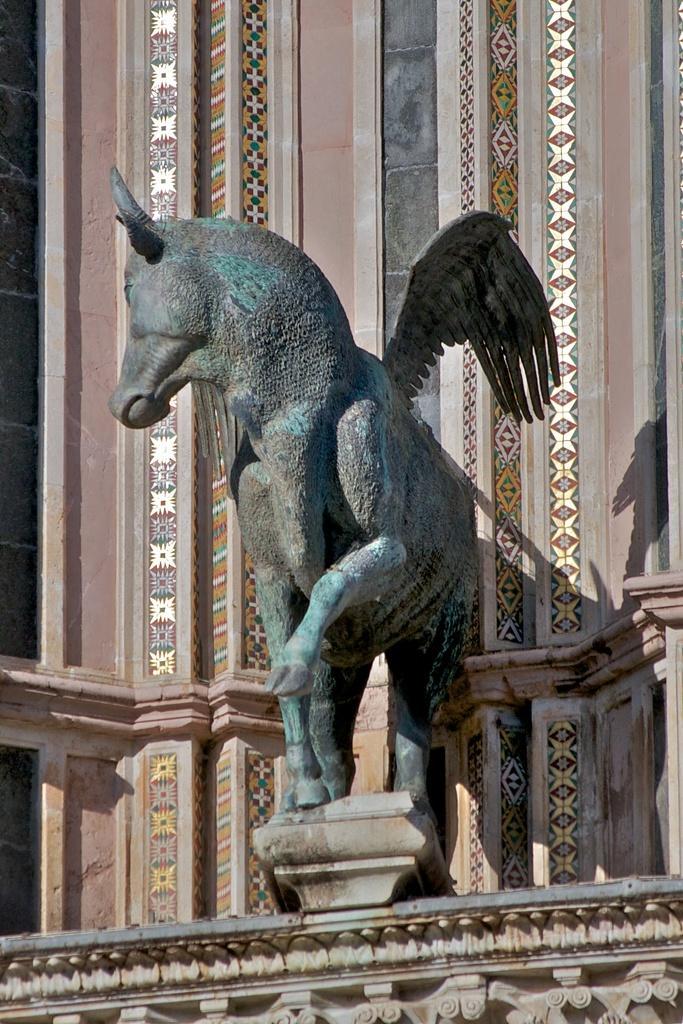Please provide a concise description of this image. Here we can see a statue of a horse with wings to it on a platform. In the background we can see a wall and some designs on it. 